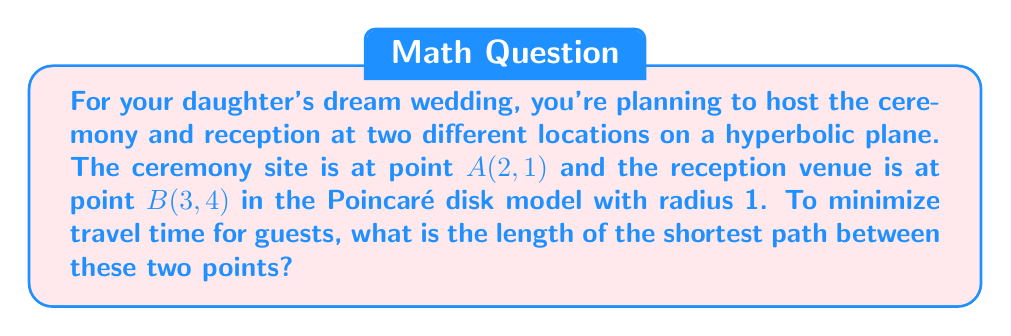Help me with this question. Let's approach this step-by-step:

1) In the Poincaré disk model of hyperbolic geometry, the shortest path between two points is along a hyperbolic line, which appears as a circular arc orthogonal to the boundary circle.

2) To find the length of this path, we use the hyperbolic distance formula:

   $$d(A,B) = \text{arcosh}\left(1 + \frac{2|A-B|^2}{(1-|A|^2)(1-|B|^2)}\right)$$

   Where $|A|$ and $|B|$ are the Euclidean distances from the origin to points A and B respectively.

3) Let's calculate $|A|$ and $|B|$:
   
   $|A| = \sqrt{2^2 + 1^2} = \sqrt{5}$
   $|B| = \sqrt{3^2 + 4^2} = 5$

4) Now, let's calculate $|A-B|$:
   
   $|A-B| = \sqrt{(3-2)^2 + (4-1)^2} = \sqrt{10}$

5) Plugging these values into our formula:

   $$d(A,B) = \text{arcosh}\left(1 + \frac{2(\sqrt{10})^2}{(1-(\sqrt{5})^2)(1-5^2)}\right)$$

6) Simplifying:

   $$d(A,B) = \text{arcosh}\left(1 + \frac{20}{(-4)(-24)}\right)$$
   
   $$d(A,B) = \text{arcosh}\left(1 + \frac{5}{24}\right)$$

7) This gives us our final answer.
Answer: $\text{arcosh}(1 + \frac{5}{24})$ 